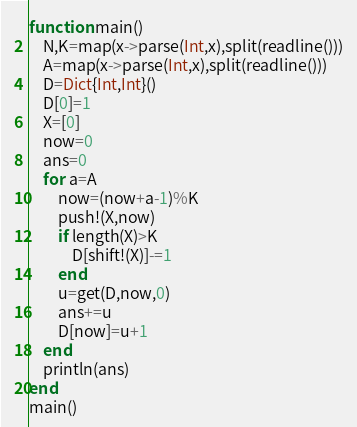Convert code to text. <code><loc_0><loc_0><loc_500><loc_500><_Julia_>function main()
	N,K=map(x->parse(Int,x),split(readline()))
	A=map(x->parse(Int,x),split(readline()))
	D=Dict{Int,Int}()
	D[0]=1
	X=[0]
	now=0
	ans=0
	for a=A
		now=(now+a-1)%K
		push!(X,now)
		if length(X)>K
			D[shift!(X)]-=1
		end
		u=get(D,now,0)
		ans+=u
		D[now]=u+1
	end
	println(ans)
end
main()
</code> 